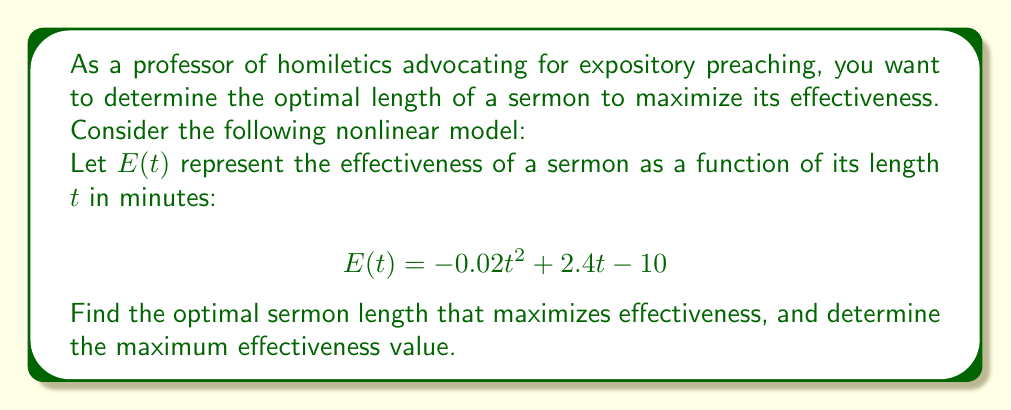Solve this math problem. To find the optimal sermon length that maximizes effectiveness, we need to follow these steps:

1. The effectiveness function $E(t)$ is a quadratic function, which forms a parabola. The maximum point of this parabola will give us the optimal sermon length.

2. To find the maximum point, we need to find the vertex of the parabola. We can do this by calculating the t-coordinate of the vertex using the formula:

   $$t = -\frac{b}{2a}$$

   where $a$ and $b$ are the coefficients of the quadratic function in the form $at^2 + bt + c$.

3. In our case, $a = -0.02$ and $b = 2.4$. Let's substitute these values:

   $$t = -\frac{2.4}{2(-0.02)} = -\frac{2.4}{-0.04} = 60$$

4. Therefore, the optimal sermon length is 60 minutes.

5. To find the maximum effectiveness, we substitute $t = 60$ into the original function:

   $$E(60) = -0.02(60)^2 + 2.4(60) - 10$$
   $$= -0.02(3600) + 144 - 10$$
   $$= -72 + 144 - 10$$
   $$= 62$$

Thus, the maximum effectiveness value is 62.
Answer: Optimal sermon length: 60 minutes; Maximum effectiveness: 62 